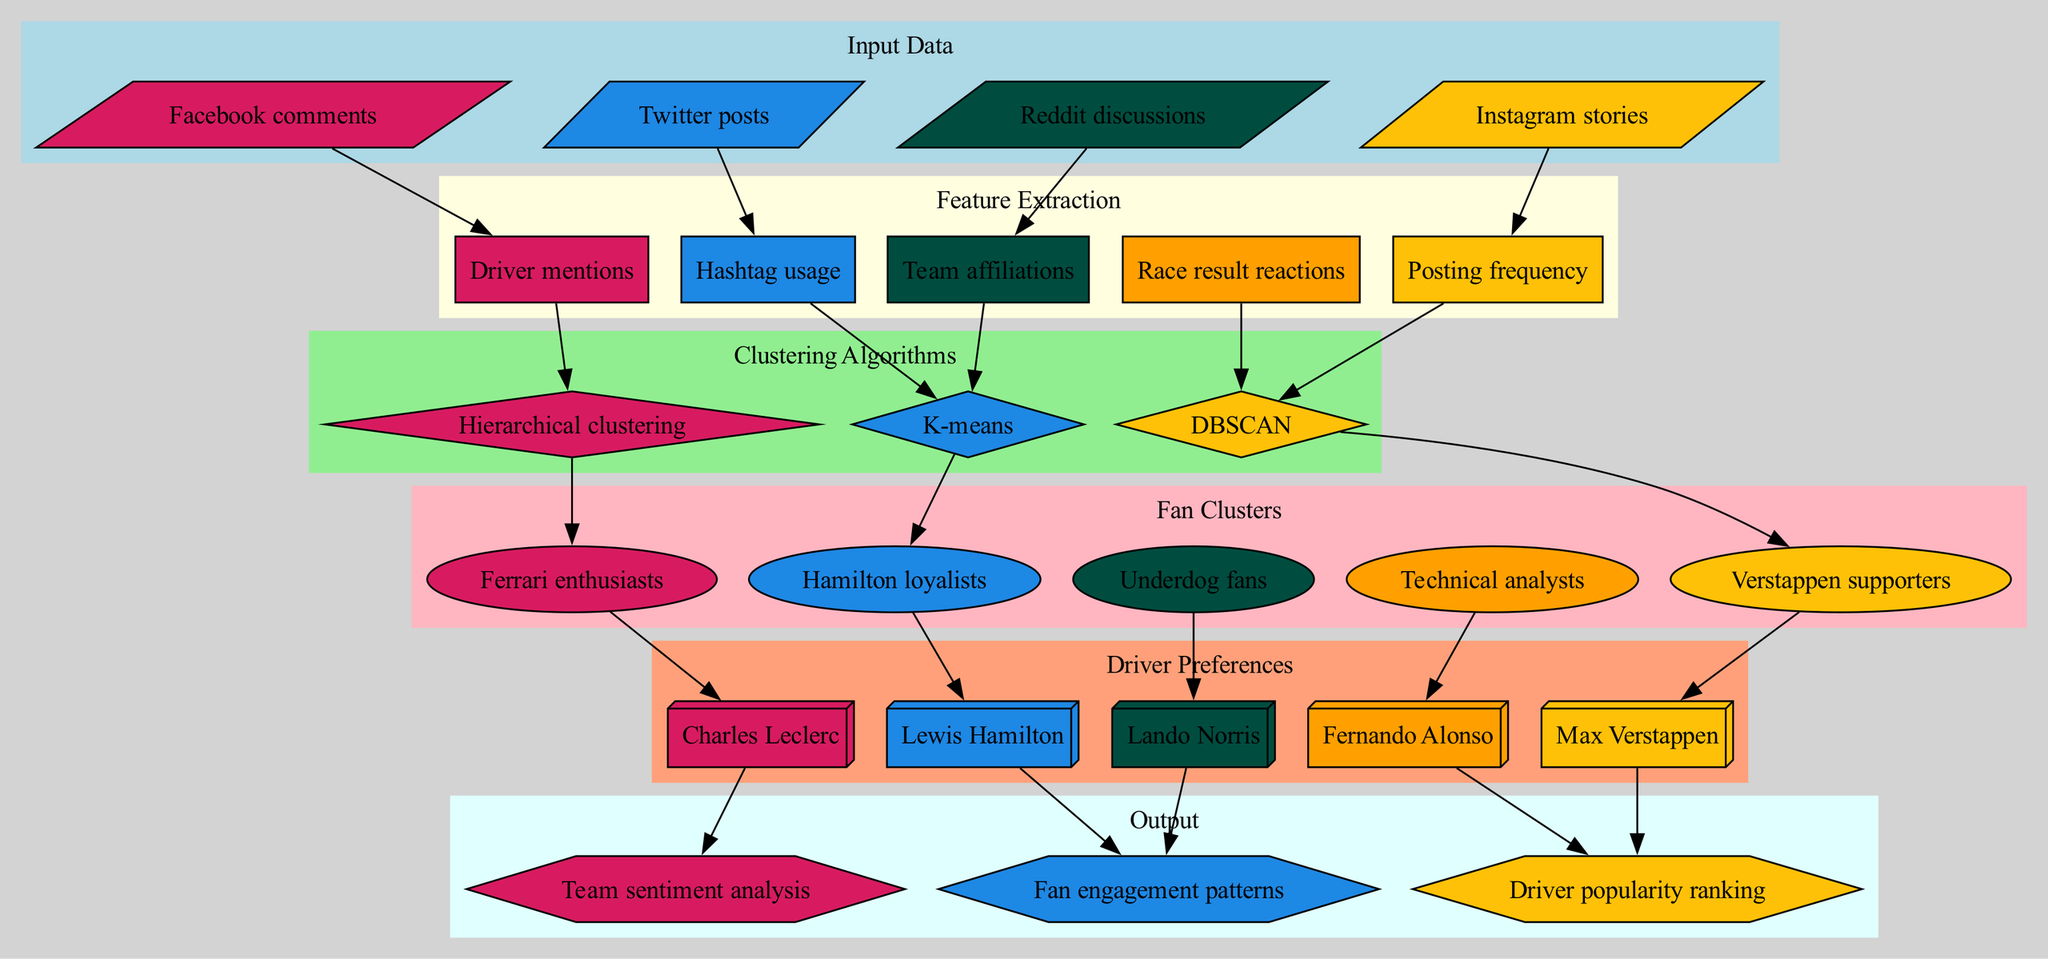What are the input data sources shown in the diagram? The diagram lists four input data sources: Twitter posts, Instagram stories, Facebook comments, and Reddit discussions, which can be found in the "Input Data" section.
Answer: Twitter posts, Instagram stories, Facebook comments, Reddit discussions What are the clustering algorithms used? The diagram illustrates three clustering algorithms: K-means, DBSCAN, and Hierarchical clustering, which are displayed under the "Clustering Algorithms" subgraph.
Answer: K-means, DBSCAN, Hierarchical clustering How many fan clusters are identified in the diagram? The diagram contains five fan clusters, which are detailed in the "Fan Clusters" section. The clusters include Hamilton loyalists, Verstappen supporters, Ferrari enthusiasts, Underdog fans, and Technical analysts.
Answer: Five What is the relationship between driver mentions and fan clusters? According to the diagram, driver mentions are extracted from the input data and are directly connected to the fan clusters, suggesting that driver preferences influence the formation of these clusters.
Answer: Directly connected What type of outputs are generated by this clustering algorithm? The diagram indicates that the outputs of this clustering process include Fan engagement patterns, Driver popularity ranking, and Team sentiment analysis, which are listed in the "Output" subgraph.
Answer: Fan engagement patterns, Driver popularity ranking, Team sentiment analysis Which driver preferences are linked to Hamilton loyalists? The diagram connects the Hamilton loyalists cluster to the Lewis Hamilton driver preference, demonstrating that this fan group favors Hamilton above others.
Answer: Lewis Hamilton What is the purpose of the feature extraction stage? The feature extraction stage is crucial as it identifies key aspects of social media engagement, such as Hashtag usage, Posting frequency, and Driver mentions, to prepare the data for clustering.
Answer: Identify key aspects How do DBSCAN and K-means relate in the clustering process? DBSCAN and K-means are listed as two different clustering algorithms that can process the features extracted from social media engagement, indicating alternative methods to group fans into clusters based on their patterns.
Answer: Alternative methods How many edges connect the input data to features in the diagram? There are four input data sources connected to various features in the diagram, resulting in four edges linking input data to feature extraction nodes.
Answer: Four 